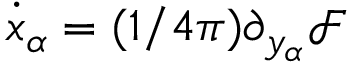<formula> <loc_0><loc_0><loc_500><loc_500>\dot { x } _ { \alpha } = ( 1 / 4 \pi ) \partial _ { y _ { \alpha } } \mathcal { F }</formula> 